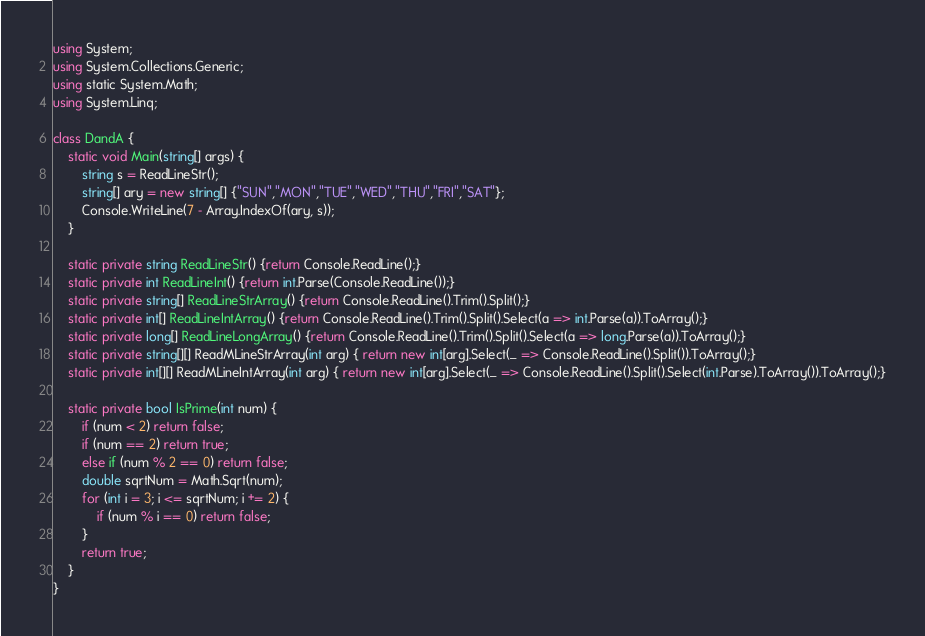Convert code to text. <code><loc_0><loc_0><loc_500><loc_500><_C#_>using System;
using System.Collections.Generic;
using static System.Math;
using System.Linq;
 
class DandA {
    static void Main(string[] args) {
        string s = ReadLineStr();
        string[] ary = new string[] {"SUN","MON","TUE","WED","THU","FRI","SAT"};
        Console.WriteLine(7 - Array.IndexOf(ary, s));
    }
  
    static private string ReadLineStr() {return Console.ReadLine();}
    static private int ReadLineInt() {return int.Parse(Console.ReadLine());}
    static private string[] ReadLineStrArray() {return Console.ReadLine().Trim().Split();}
    static private int[] ReadLineIntArray() {return Console.ReadLine().Trim().Split().Select(a => int.Parse(a)).ToArray();}
    static private long[] ReadLineLongArray() {return Console.ReadLine().Trim().Split().Select(a => long.Parse(a)).ToArray();}
    static private string[][] ReadMLineStrArray(int arg) { return new int[arg].Select(_ => Console.ReadLine().Split()).ToArray();}
    static private int[][] ReadMLineIntArray(int arg) { return new int[arg].Select(_ => Console.ReadLine().Split().Select(int.Parse).ToArray()).ToArray();}

    static private bool IsPrime(int num) {
        if (num < 2) return false;
        if (num == 2) return true;
        else if (num % 2 == 0) return false;
        double sqrtNum = Math.Sqrt(num);
        for (int i = 3; i <= sqrtNum; i += 2) {
            if (num % i == 0) return false;
        }
        return true;
    }
}</code> 